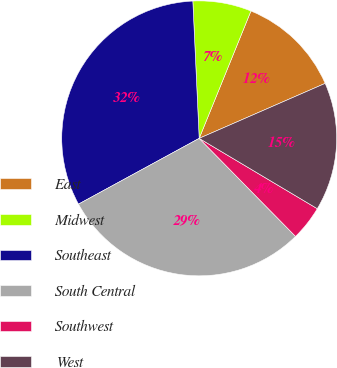<chart> <loc_0><loc_0><loc_500><loc_500><pie_chart><fcel>East<fcel>Midwest<fcel>Southeast<fcel>South Central<fcel>Southwest<fcel>West<nl><fcel>12.31%<fcel>6.88%<fcel>32.21%<fcel>29.42%<fcel>4.09%<fcel>15.1%<nl></chart> 